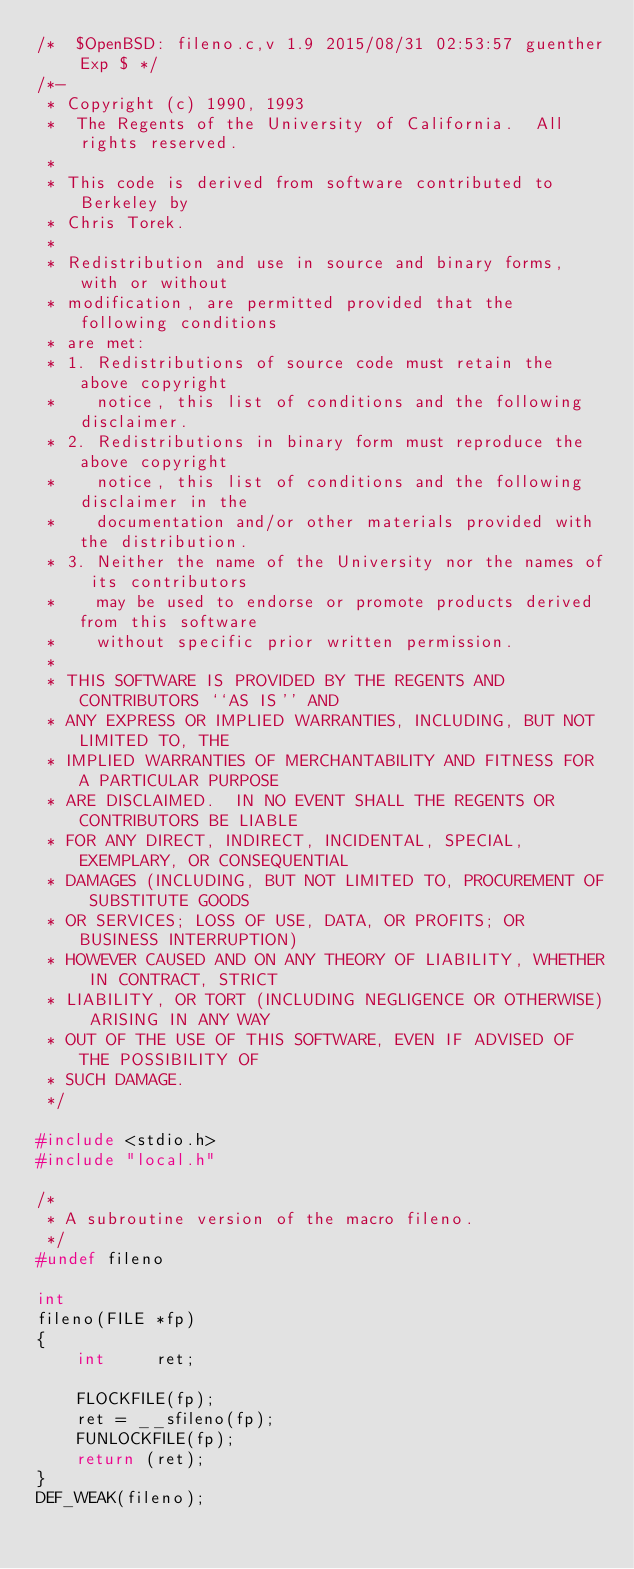Convert code to text. <code><loc_0><loc_0><loc_500><loc_500><_C_>/*	$OpenBSD: fileno.c,v 1.9 2015/08/31 02:53:57 guenther Exp $ */
/*-
 * Copyright (c) 1990, 1993
 *	The Regents of the University of California.  All rights reserved.
 *
 * This code is derived from software contributed to Berkeley by
 * Chris Torek.
 *
 * Redistribution and use in source and binary forms, with or without
 * modification, are permitted provided that the following conditions
 * are met:
 * 1. Redistributions of source code must retain the above copyright
 *    notice, this list of conditions and the following disclaimer.
 * 2. Redistributions in binary form must reproduce the above copyright
 *    notice, this list of conditions and the following disclaimer in the
 *    documentation and/or other materials provided with the distribution.
 * 3. Neither the name of the University nor the names of its contributors
 *    may be used to endorse or promote products derived from this software
 *    without specific prior written permission.
 *
 * THIS SOFTWARE IS PROVIDED BY THE REGENTS AND CONTRIBUTORS ``AS IS'' AND
 * ANY EXPRESS OR IMPLIED WARRANTIES, INCLUDING, BUT NOT LIMITED TO, THE
 * IMPLIED WARRANTIES OF MERCHANTABILITY AND FITNESS FOR A PARTICULAR PURPOSE
 * ARE DISCLAIMED.  IN NO EVENT SHALL THE REGENTS OR CONTRIBUTORS BE LIABLE
 * FOR ANY DIRECT, INDIRECT, INCIDENTAL, SPECIAL, EXEMPLARY, OR CONSEQUENTIAL
 * DAMAGES (INCLUDING, BUT NOT LIMITED TO, PROCUREMENT OF SUBSTITUTE GOODS
 * OR SERVICES; LOSS OF USE, DATA, OR PROFITS; OR BUSINESS INTERRUPTION)
 * HOWEVER CAUSED AND ON ANY THEORY OF LIABILITY, WHETHER IN CONTRACT, STRICT
 * LIABILITY, OR TORT (INCLUDING NEGLIGENCE OR OTHERWISE) ARISING IN ANY WAY
 * OUT OF THE USE OF THIS SOFTWARE, EVEN IF ADVISED OF THE POSSIBILITY OF
 * SUCH DAMAGE.
 */

#include <stdio.h>
#include "local.h"

/*
 * A subroutine version of the macro fileno.
 */
#undef fileno

int
fileno(FILE *fp)
{
	int     ret;

	FLOCKFILE(fp);
	ret = __sfileno(fp);
	FUNLOCKFILE(fp);
	return (ret);
}
DEF_WEAK(fileno);
</code> 